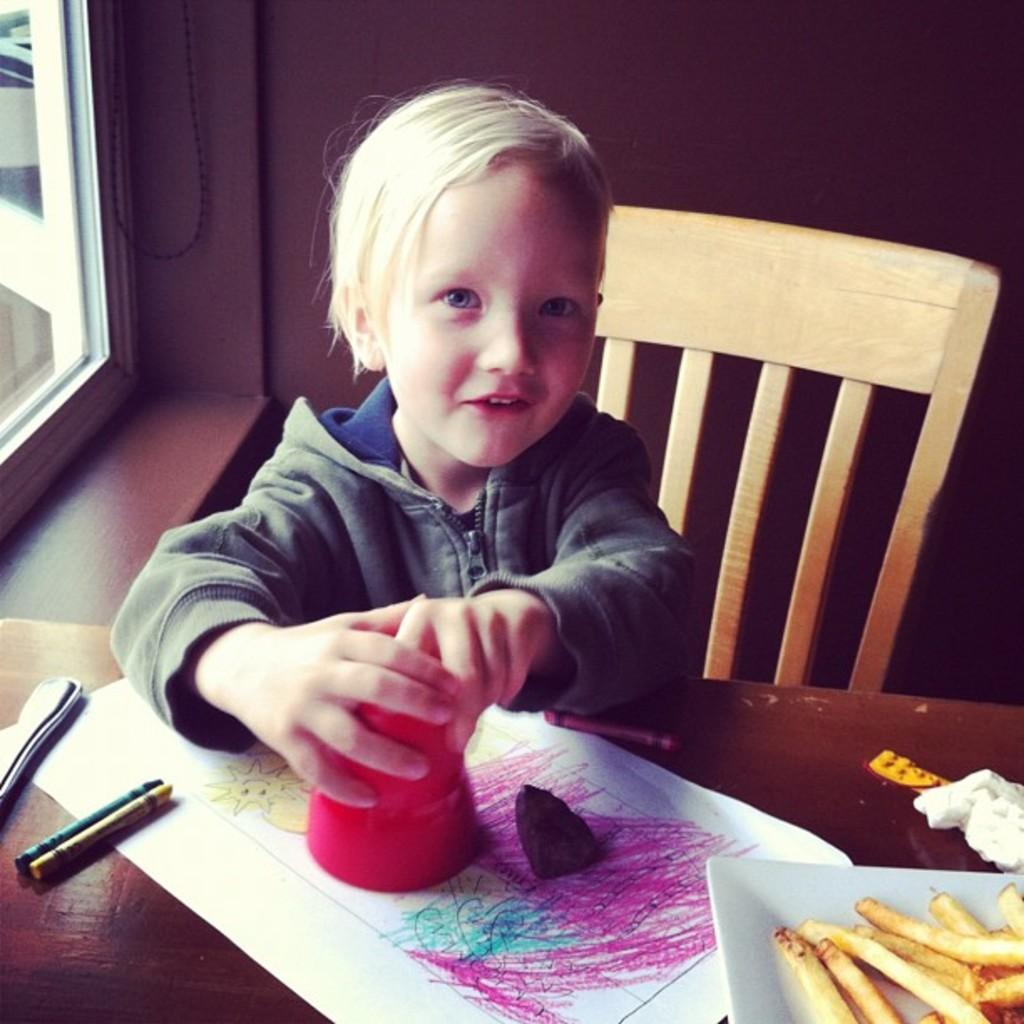What is the boy doing in the image? The boy is sitting on a chair in the image. What is located near the boy? There is a table in the image. What items can be seen on the table? There is a glass, a paper, a pen, a tray, and food on the table. What can be seen outside the room in the image? There is a window in the image, which suggests a view of the outdoors. What is the setting of the image? There is a wall in the image, which indicates that the boy is likely in a room. What type of comfort can be seen in the image? There is no specific comfort item visible in the image. What type of branch is growing through the window in the image? There is no branch visible in the image; only a window is mentioned. 